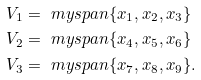Convert formula to latex. <formula><loc_0><loc_0><loc_500><loc_500>V _ { 1 } & = \ m y s p a n \{ x _ { 1 } , x _ { 2 } , x _ { 3 } \} \\ V _ { 2 } & = \ m y s p a n \{ x _ { 4 } , x _ { 5 } , x _ { 6 } \} \\ V _ { 3 } & = \ m y s p a n \{ x _ { 7 } , x _ { 8 } , x _ { 9 } \} .</formula> 